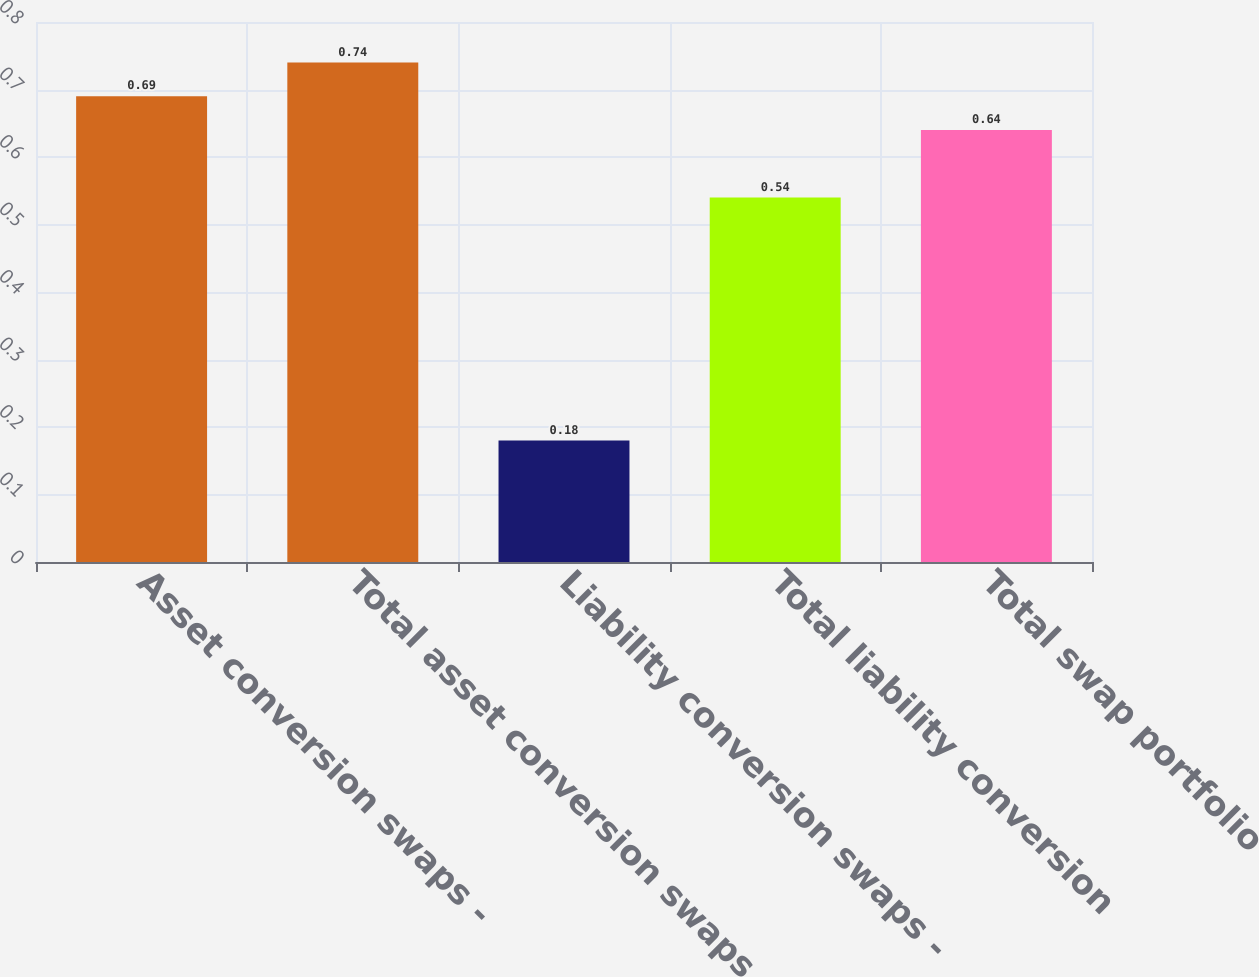<chart> <loc_0><loc_0><loc_500><loc_500><bar_chart><fcel>Asset conversion swaps -<fcel>Total asset conversion swaps<fcel>Liability conversion swaps -<fcel>Total liability conversion<fcel>Total swap portfolio<nl><fcel>0.69<fcel>0.74<fcel>0.18<fcel>0.54<fcel>0.64<nl></chart> 